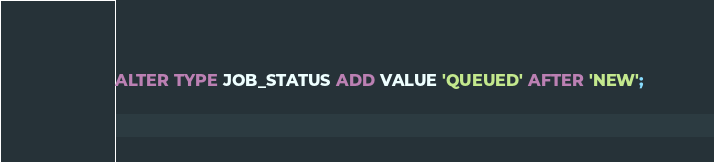Convert code to text. <code><loc_0><loc_0><loc_500><loc_500><_SQL_>ALTER TYPE JOB_STATUS ADD VALUE 'QUEUED' AFTER 'NEW';</code> 